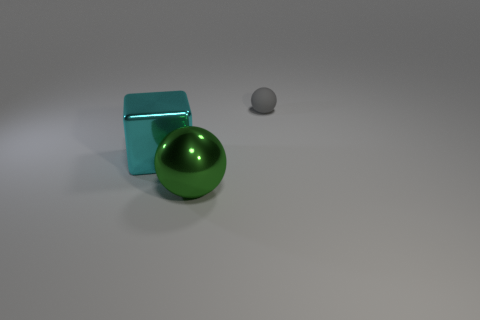How would you describe the texture and color contrast in this image? The texture of the objects appears smooth and unblemished, with a notable contrast between the vibrant green, muted grey, and the teal-colored cube. This juxtaposition highlights their individual forms and creates a visually interesting composition. 